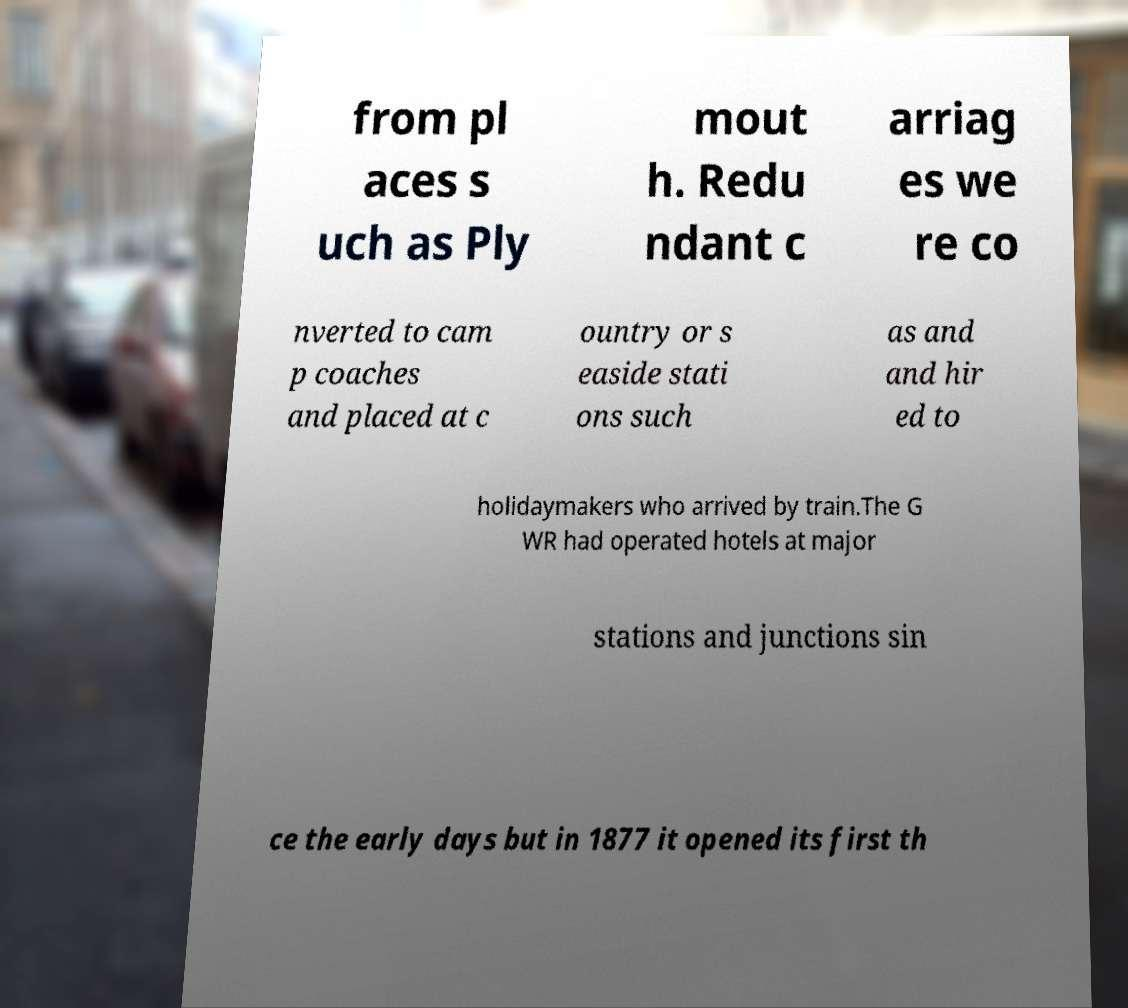For documentation purposes, I need the text within this image transcribed. Could you provide that? from pl aces s uch as Ply mout h. Redu ndant c arriag es we re co nverted to cam p coaches and placed at c ountry or s easide stati ons such as and and hir ed to holidaymakers who arrived by train.The G WR had operated hotels at major stations and junctions sin ce the early days but in 1877 it opened its first th 